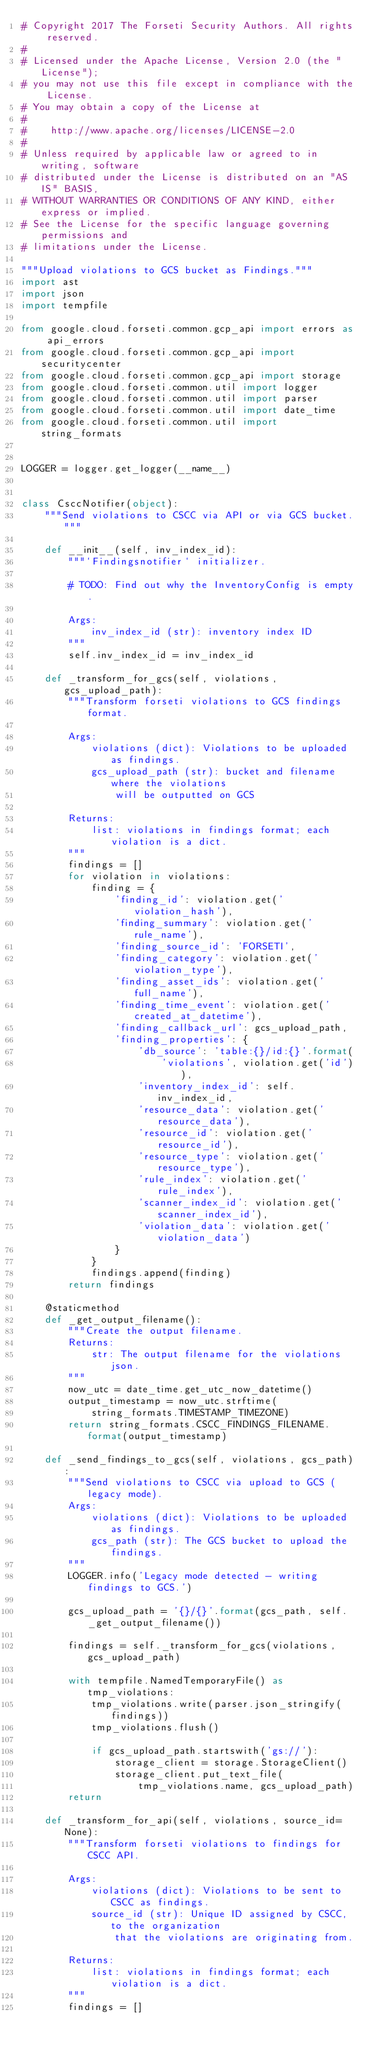Convert code to text. <code><loc_0><loc_0><loc_500><loc_500><_Python_># Copyright 2017 The Forseti Security Authors. All rights reserved.
#
# Licensed under the Apache License, Version 2.0 (the "License");
# you may not use this file except in compliance with the License.
# You may obtain a copy of the License at
#
#    http://www.apache.org/licenses/LICENSE-2.0
#
# Unless required by applicable law or agreed to in writing, software
# distributed under the License is distributed on an "AS IS" BASIS,
# WITHOUT WARRANTIES OR CONDITIONS OF ANY KIND, either express or implied.
# See the License for the specific language governing permissions and
# limitations under the License.

"""Upload violations to GCS bucket as Findings."""
import ast
import json
import tempfile

from google.cloud.forseti.common.gcp_api import errors as api_errors
from google.cloud.forseti.common.gcp_api import securitycenter
from google.cloud.forseti.common.gcp_api import storage
from google.cloud.forseti.common.util import logger
from google.cloud.forseti.common.util import parser
from google.cloud.forseti.common.util import date_time
from google.cloud.forseti.common.util import string_formats


LOGGER = logger.get_logger(__name__)


class CsccNotifier(object):
    """Send violations to CSCC via API or via GCS bucket."""

    def __init__(self, inv_index_id):
        """`Findingsnotifier` initializer.

        # TODO: Find out why the InventoryConfig is empty.

        Args:
            inv_index_id (str): inventory index ID
        """
        self.inv_index_id = inv_index_id

    def _transform_for_gcs(self, violations, gcs_upload_path):
        """Transform forseti violations to GCS findings format.

        Args:
            violations (dict): Violations to be uploaded as findings.
            gcs_upload_path (str): bucket and filename where the violations
                will be outputted on GCS

        Returns:
            list: violations in findings format; each violation is a dict.
        """
        findings = []
        for violation in violations:
            finding = {
                'finding_id': violation.get('violation_hash'),
                'finding_summary': violation.get('rule_name'),
                'finding_source_id': 'FORSETI',
                'finding_category': violation.get('violation_type'),
                'finding_asset_ids': violation.get('full_name'),
                'finding_time_event': violation.get('created_at_datetime'),
                'finding_callback_url': gcs_upload_path,
                'finding_properties': {
                    'db_source': 'table:{}/id:{}'.format(
                        'violations', violation.get('id')),
                    'inventory_index_id': self.inv_index_id,
                    'resource_data': violation.get('resource_data'),
                    'resource_id': violation.get('resource_id'),
                    'resource_type': violation.get('resource_type'),
                    'rule_index': violation.get('rule_index'),
                    'scanner_index_id': violation.get('scanner_index_id'),
                    'violation_data': violation.get('violation_data')
                }
            }
            findings.append(finding)
        return findings

    @staticmethod
    def _get_output_filename():
        """Create the output filename.
        Returns:
            str: The output filename for the violations json.
        """
        now_utc = date_time.get_utc_now_datetime()
        output_timestamp = now_utc.strftime(
            string_formats.TIMESTAMP_TIMEZONE)
        return string_formats.CSCC_FINDINGS_FILENAME.format(output_timestamp)

    def _send_findings_to_gcs(self, violations, gcs_path):
        """Send violations to CSCC via upload to GCS (legacy mode).
        Args:
            violations (dict): Violations to be uploaded as findings.
            gcs_path (str): The GCS bucket to upload the findings.
        """
        LOGGER.info('Legacy mode detected - writing findings to GCS.')

        gcs_upload_path = '{}/{}'.format(gcs_path, self._get_output_filename())

        findings = self._transform_for_gcs(violations, gcs_upload_path)

        with tempfile.NamedTemporaryFile() as tmp_violations:
            tmp_violations.write(parser.json_stringify(findings))
            tmp_violations.flush()

            if gcs_upload_path.startswith('gs://'):
                storage_client = storage.StorageClient()
                storage_client.put_text_file(
                    tmp_violations.name, gcs_upload_path)
        return

    def _transform_for_api(self, violations, source_id=None):
        """Transform forseti violations to findings for CSCC API.

        Args:
            violations (dict): Violations to be sent to CSCC as findings.
            source_id (str): Unique ID assigned by CSCC, to the organization
                that the violations are originating from.

        Returns:
            list: violations in findings format; each violation is a dict.
        """
        findings = []
</code> 